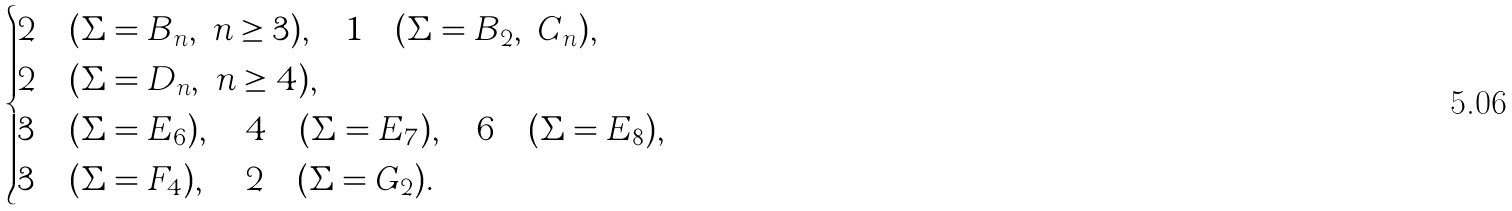Convert formula to latex. <formula><loc_0><loc_0><loc_500><loc_500>\begin{cases} 2 & ( \Sigma = B _ { n } , \ n \geq 3 ) , \quad 1 \quad ( \Sigma = B _ { 2 } , \ C _ { n } ) , \\ 2 & ( \Sigma = D _ { n } , \ n \geq 4 ) , \\ 3 & ( \Sigma = E _ { 6 } ) , \quad 4 \quad ( \Sigma = E _ { 7 } ) , \quad 6 \quad ( \Sigma = E _ { 8 } ) , \\ 3 & ( \Sigma = F _ { 4 } ) , \, \quad 2 \quad ( \Sigma = G _ { 2 } ) . \end{cases}</formula> 